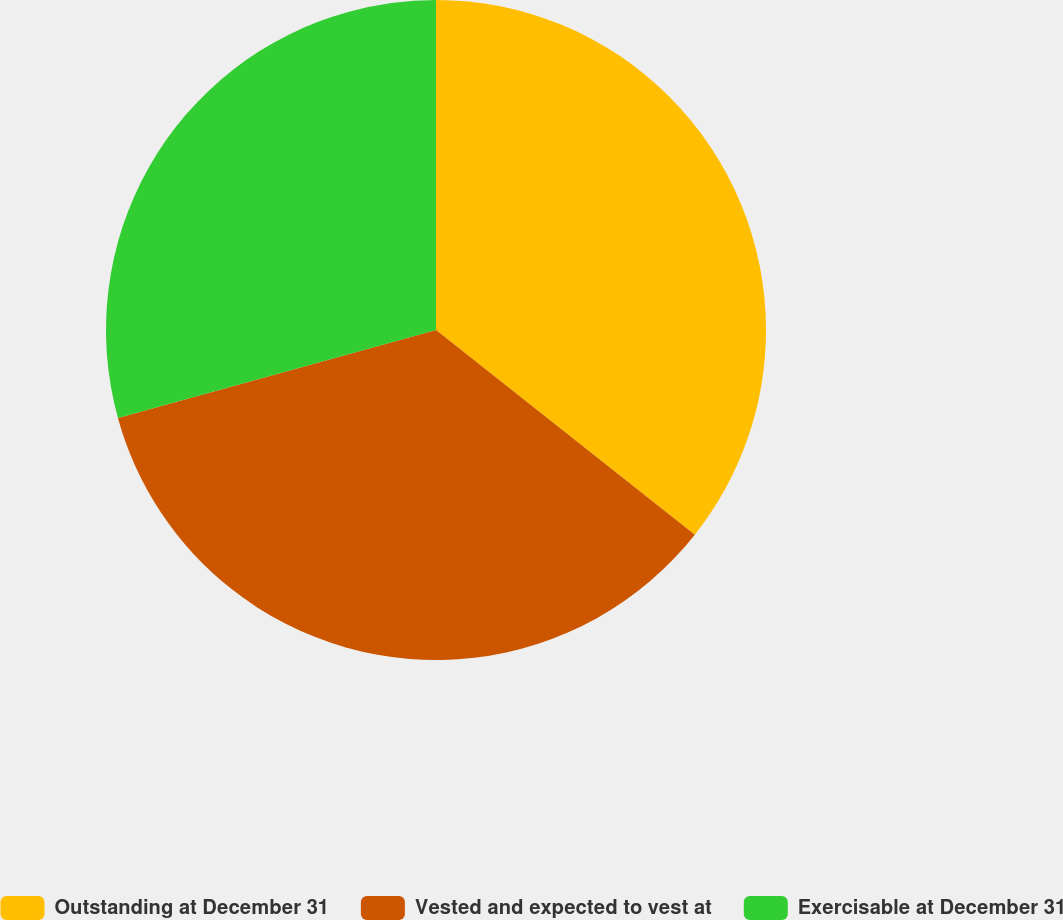<chart> <loc_0><loc_0><loc_500><loc_500><pie_chart><fcel>Outstanding at December 31<fcel>Vested and expected to vest at<fcel>Exercisable at December 31<nl><fcel>35.65%<fcel>35.06%<fcel>29.29%<nl></chart> 